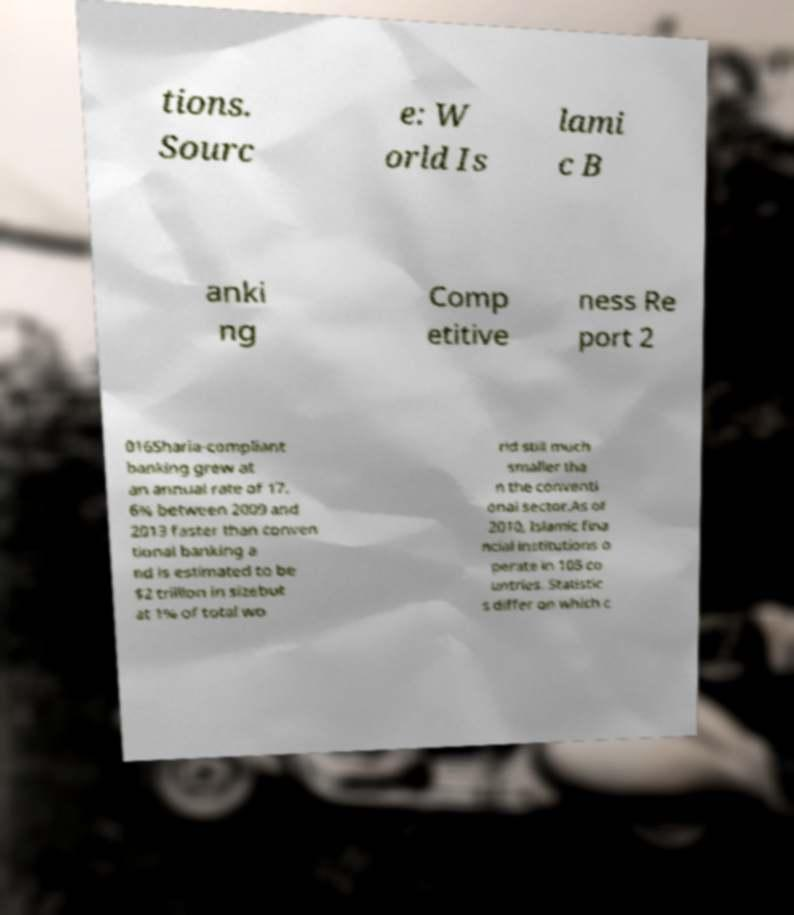Could you assist in decoding the text presented in this image and type it out clearly? tions. Sourc e: W orld Is lami c B anki ng Comp etitive ness Re port 2 016Sharia-compliant banking grew at an annual rate of 17. 6% between 2009 and 2013 faster than conven tional banking a nd is estimated to be $2 trillion in sizebut at 1% of total wo rld still much smaller tha n the conventi onal sector.As of 2010, Islamic fina ncial institutions o perate in 105 co untries. Statistic s differ on which c 